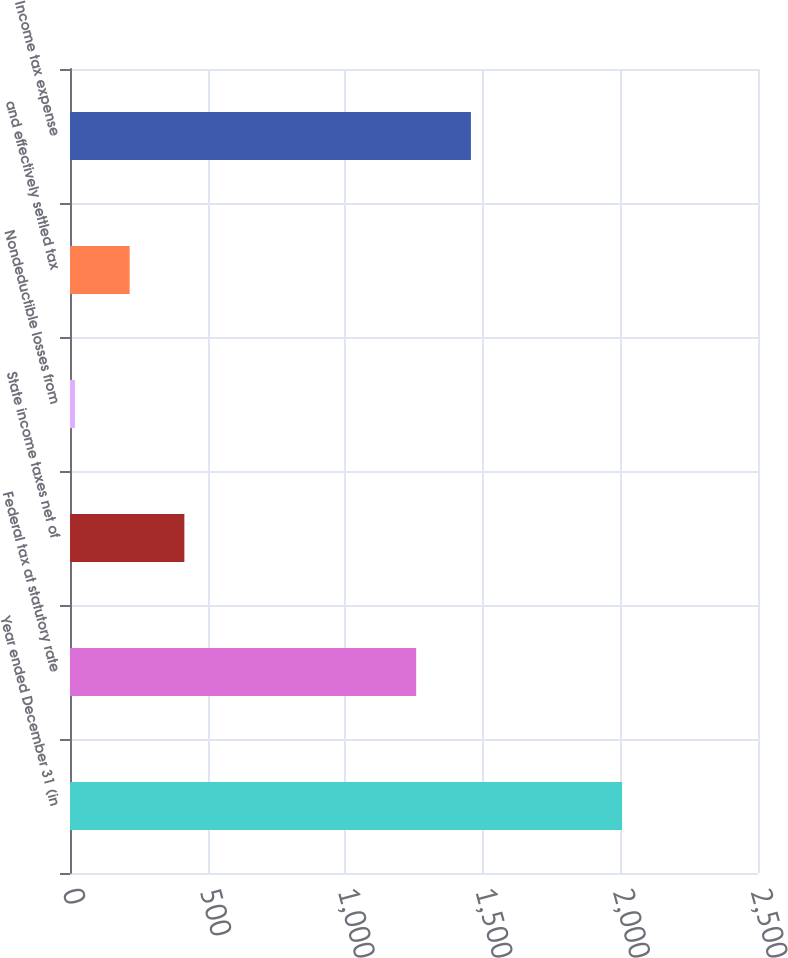Convert chart. <chart><loc_0><loc_0><loc_500><loc_500><bar_chart><fcel>Year ended December 31 (in<fcel>Federal tax at statutory rate<fcel>State income taxes net of<fcel>Nondeductible losses from<fcel>and effectively settled tax<fcel>Income tax expense<nl><fcel>2006<fcel>1258<fcel>415.6<fcel>18<fcel>216.8<fcel>1456.8<nl></chart> 